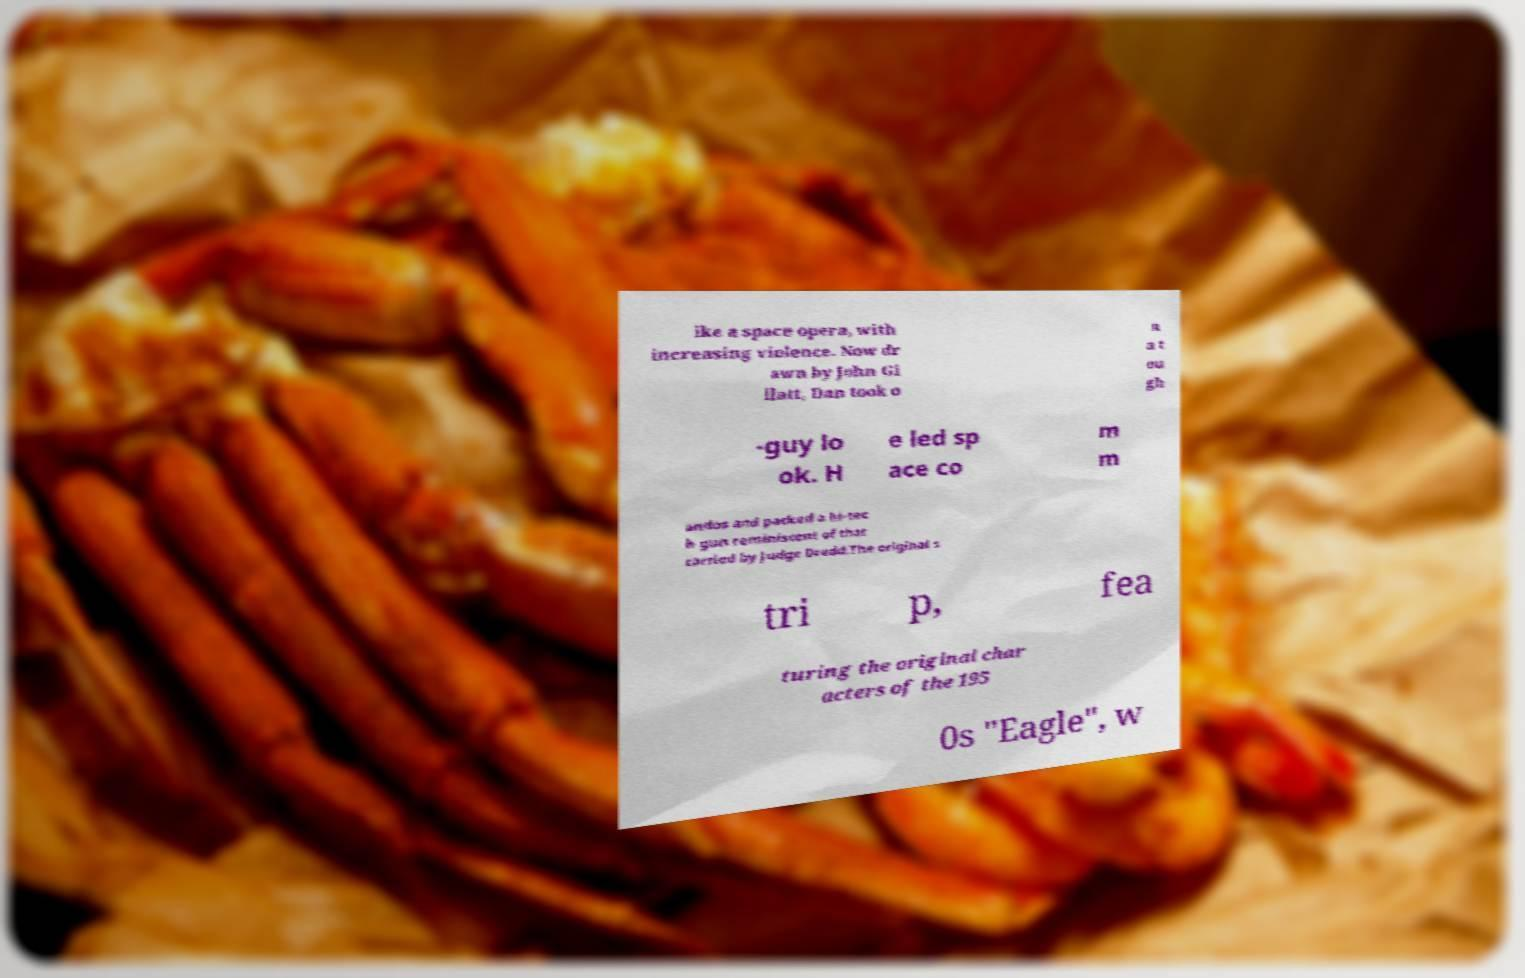There's text embedded in this image that I need extracted. Can you transcribe it verbatim? ike a space opera, with increasing violence. Now dr awn by John Gi llatt, Dan took o n a t ou gh -guy lo ok. H e led sp ace co m m andos and packed a hi-tec h gun reminiscent of that carried by Judge Dredd.The original s tri p, fea turing the original char acters of the 195 0s "Eagle", w 